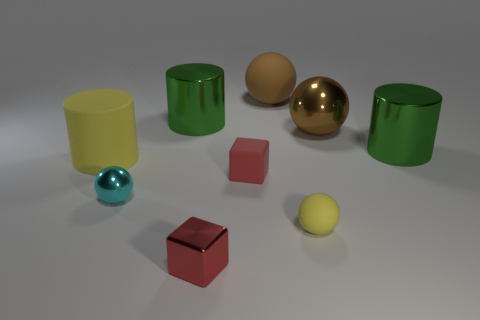Subtract all large metal cylinders. How many cylinders are left? 1 Subtract all cyan balls. How many balls are left? 3 Subtract 1 cylinders. How many cylinders are left? 2 Add 1 big brown matte spheres. How many objects exist? 10 Subtract all green spheres. Subtract all brown cylinders. How many spheres are left? 4 Subtract all spheres. How many objects are left? 5 Subtract all cyan metallic spheres. Subtract all big yellow cylinders. How many objects are left? 7 Add 4 brown rubber balls. How many brown rubber balls are left? 5 Add 5 big cyan matte spheres. How many big cyan matte spheres exist? 5 Subtract 1 yellow balls. How many objects are left? 8 